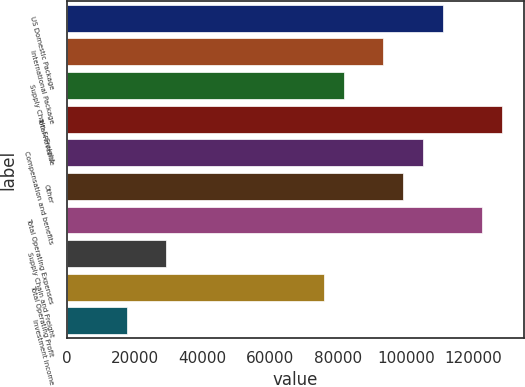<chart> <loc_0><loc_0><loc_500><loc_500><bar_chart><fcel>US Domestic Package<fcel>International Package<fcel>Supply Chain & Freight<fcel>Total Revenue<fcel>Compensation and benefits<fcel>Other<fcel>Total Operating Expenses<fcel>Supply Chain and Freight<fcel>Total Operating Profit<fcel>Investment income<nl><fcel>110887<fcel>93379.1<fcel>81707.1<fcel>128395<fcel>105051<fcel>99215.1<fcel>122559<fcel>29183<fcel>75871.1<fcel>17511<nl></chart> 